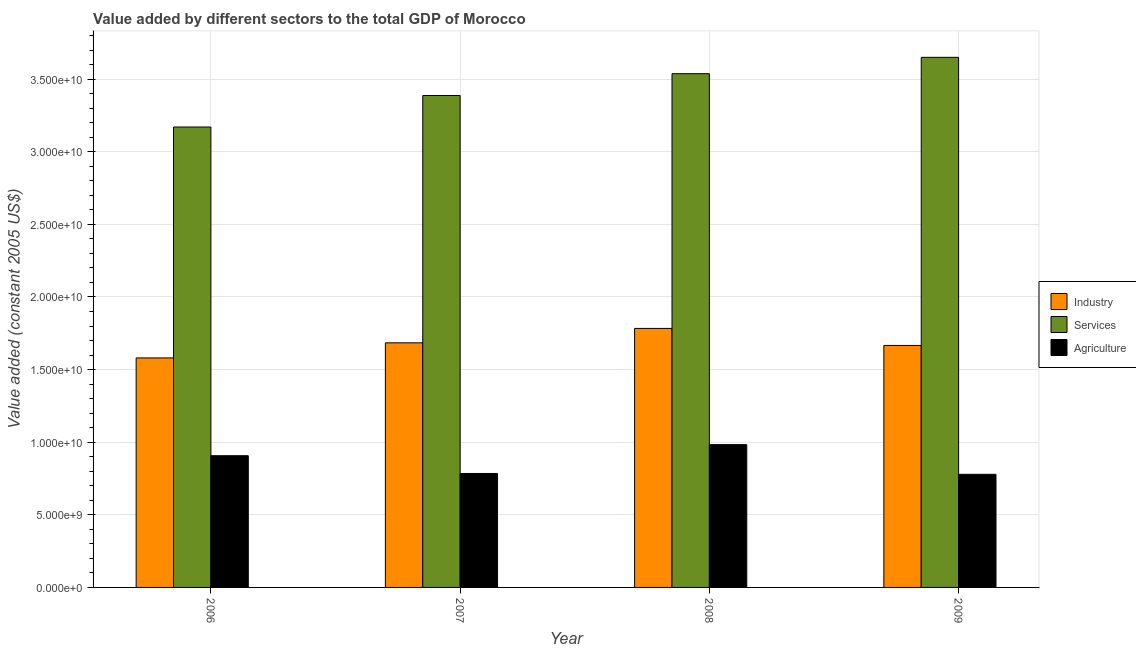How many different coloured bars are there?
Keep it short and to the point. 3. Are the number of bars on each tick of the X-axis equal?
Provide a succinct answer. Yes. How many bars are there on the 3rd tick from the left?
Ensure brevity in your answer.  3. What is the label of the 4th group of bars from the left?
Offer a very short reply. 2009. In how many cases, is the number of bars for a given year not equal to the number of legend labels?
Keep it short and to the point. 0. What is the value added by services in 2008?
Offer a terse response. 3.54e+1. Across all years, what is the maximum value added by services?
Offer a terse response. 3.65e+1. Across all years, what is the minimum value added by industrial sector?
Provide a short and direct response. 1.58e+1. In which year was the value added by services maximum?
Offer a terse response. 2009. In which year was the value added by services minimum?
Provide a short and direct response. 2006. What is the total value added by services in the graph?
Provide a short and direct response. 1.37e+11. What is the difference between the value added by agricultural sector in 2007 and that in 2009?
Provide a short and direct response. 5.80e+07. What is the difference between the value added by agricultural sector in 2007 and the value added by industrial sector in 2006?
Provide a short and direct response. -1.22e+09. What is the average value added by agricultural sector per year?
Give a very brief answer. 8.64e+09. In the year 2008, what is the difference between the value added by services and value added by agricultural sector?
Offer a terse response. 0. What is the ratio of the value added by agricultural sector in 2006 to that in 2008?
Keep it short and to the point. 0.92. Is the value added by services in 2006 less than that in 2008?
Make the answer very short. Yes. What is the difference between the highest and the second highest value added by agricultural sector?
Offer a very short reply. 7.64e+08. What is the difference between the highest and the lowest value added by agricultural sector?
Ensure brevity in your answer.  2.04e+09. In how many years, is the value added by services greater than the average value added by services taken over all years?
Make the answer very short. 2. Is the sum of the value added by industrial sector in 2008 and 2009 greater than the maximum value added by agricultural sector across all years?
Offer a very short reply. Yes. What does the 2nd bar from the left in 2009 represents?
Ensure brevity in your answer.  Services. What does the 1st bar from the right in 2008 represents?
Give a very brief answer. Agriculture. Is it the case that in every year, the sum of the value added by industrial sector and value added by services is greater than the value added by agricultural sector?
Your answer should be very brief. Yes. Are all the bars in the graph horizontal?
Provide a succinct answer. No. How many years are there in the graph?
Ensure brevity in your answer.  4. What is the difference between two consecutive major ticks on the Y-axis?
Make the answer very short. 5.00e+09. Are the values on the major ticks of Y-axis written in scientific E-notation?
Offer a terse response. Yes. Does the graph contain any zero values?
Provide a short and direct response. No. How many legend labels are there?
Give a very brief answer. 3. How are the legend labels stacked?
Provide a short and direct response. Vertical. What is the title of the graph?
Your answer should be very brief. Value added by different sectors to the total GDP of Morocco. Does "Social insurance" appear as one of the legend labels in the graph?
Make the answer very short. No. What is the label or title of the X-axis?
Keep it short and to the point. Year. What is the label or title of the Y-axis?
Provide a short and direct response. Value added (constant 2005 US$). What is the Value added (constant 2005 US$) of Industry in 2006?
Give a very brief answer. 1.58e+1. What is the Value added (constant 2005 US$) in Services in 2006?
Provide a short and direct response. 3.17e+1. What is the Value added (constant 2005 US$) of Agriculture in 2006?
Offer a terse response. 9.07e+09. What is the Value added (constant 2005 US$) of Industry in 2007?
Make the answer very short. 1.68e+1. What is the Value added (constant 2005 US$) in Services in 2007?
Your response must be concise. 3.39e+1. What is the Value added (constant 2005 US$) of Agriculture in 2007?
Your answer should be compact. 7.85e+09. What is the Value added (constant 2005 US$) of Industry in 2008?
Give a very brief answer. 1.78e+1. What is the Value added (constant 2005 US$) of Services in 2008?
Your answer should be very brief. 3.54e+1. What is the Value added (constant 2005 US$) in Agriculture in 2008?
Provide a short and direct response. 9.83e+09. What is the Value added (constant 2005 US$) in Industry in 2009?
Provide a succinct answer. 1.67e+1. What is the Value added (constant 2005 US$) of Services in 2009?
Your response must be concise. 3.65e+1. What is the Value added (constant 2005 US$) of Agriculture in 2009?
Offer a very short reply. 7.79e+09. Across all years, what is the maximum Value added (constant 2005 US$) of Industry?
Make the answer very short. 1.78e+1. Across all years, what is the maximum Value added (constant 2005 US$) of Services?
Make the answer very short. 3.65e+1. Across all years, what is the maximum Value added (constant 2005 US$) of Agriculture?
Offer a terse response. 9.83e+09. Across all years, what is the minimum Value added (constant 2005 US$) of Industry?
Provide a succinct answer. 1.58e+1. Across all years, what is the minimum Value added (constant 2005 US$) in Services?
Give a very brief answer. 3.17e+1. Across all years, what is the minimum Value added (constant 2005 US$) of Agriculture?
Give a very brief answer. 7.79e+09. What is the total Value added (constant 2005 US$) in Industry in the graph?
Provide a short and direct response. 6.71e+1. What is the total Value added (constant 2005 US$) in Services in the graph?
Make the answer very short. 1.37e+11. What is the total Value added (constant 2005 US$) of Agriculture in the graph?
Provide a short and direct response. 3.45e+1. What is the difference between the Value added (constant 2005 US$) of Industry in 2006 and that in 2007?
Your response must be concise. -1.04e+09. What is the difference between the Value added (constant 2005 US$) of Services in 2006 and that in 2007?
Provide a succinct answer. -2.17e+09. What is the difference between the Value added (constant 2005 US$) of Agriculture in 2006 and that in 2007?
Your response must be concise. 1.22e+09. What is the difference between the Value added (constant 2005 US$) of Industry in 2006 and that in 2008?
Provide a short and direct response. -2.03e+09. What is the difference between the Value added (constant 2005 US$) in Services in 2006 and that in 2008?
Your answer should be compact. -3.67e+09. What is the difference between the Value added (constant 2005 US$) in Agriculture in 2006 and that in 2008?
Offer a very short reply. -7.64e+08. What is the difference between the Value added (constant 2005 US$) of Industry in 2006 and that in 2009?
Keep it short and to the point. -8.59e+08. What is the difference between the Value added (constant 2005 US$) of Services in 2006 and that in 2009?
Make the answer very short. -4.80e+09. What is the difference between the Value added (constant 2005 US$) in Agriculture in 2006 and that in 2009?
Provide a succinct answer. 1.28e+09. What is the difference between the Value added (constant 2005 US$) in Industry in 2007 and that in 2008?
Ensure brevity in your answer.  -9.94e+08. What is the difference between the Value added (constant 2005 US$) in Services in 2007 and that in 2008?
Your response must be concise. -1.50e+09. What is the difference between the Value added (constant 2005 US$) of Agriculture in 2007 and that in 2008?
Make the answer very short. -1.99e+09. What is the difference between the Value added (constant 2005 US$) in Industry in 2007 and that in 2009?
Offer a very short reply. 1.79e+08. What is the difference between the Value added (constant 2005 US$) in Services in 2007 and that in 2009?
Keep it short and to the point. -2.63e+09. What is the difference between the Value added (constant 2005 US$) in Agriculture in 2007 and that in 2009?
Provide a succinct answer. 5.80e+07. What is the difference between the Value added (constant 2005 US$) in Industry in 2008 and that in 2009?
Your answer should be compact. 1.17e+09. What is the difference between the Value added (constant 2005 US$) in Services in 2008 and that in 2009?
Your answer should be very brief. -1.13e+09. What is the difference between the Value added (constant 2005 US$) in Agriculture in 2008 and that in 2009?
Keep it short and to the point. 2.04e+09. What is the difference between the Value added (constant 2005 US$) of Industry in 2006 and the Value added (constant 2005 US$) of Services in 2007?
Ensure brevity in your answer.  -1.81e+1. What is the difference between the Value added (constant 2005 US$) of Industry in 2006 and the Value added (constant 2005 US$) of Agriculture in 2007?
Give a very brief answer. 7.96e+09. What is the difference between the Value added (constant 2005 US$) of Services in 2006 and the Value added (constant 2005 US$) of Agriculture in 2007?
Provide a short and direct response. 2.39e+1. What is the difference between the Value added (constant 2005 US$) in Industry in 2006 and the Value added (constant 2005 US$) in Services in 2008?
Offer a very short reply. -1.96e+1. What is the difference between the Value added (constant 2005 US$) of Industry in 2006 and the Value added (constant 2005 US$) of Agriculture in 2008?
Keep it short and to the point. 5.97e+09. What is the difference between the Value added (constant 2005 US$) of Services in 2006 and the Value added (constant 2005 US$) of Agriculture in 2008?
Provide a succinct answer. 2.19e+1. What is the difference between the Value added (constant 2005 US$) in Industry in 2006 and the Value added (constant 2005 US$) in Services in 2009?
Your response must be concise. -2.07e+1. What is the difference between the Value added (constant 2005 US$) in Industry in 2006 and the Value added (constant 2005 US$) in Agriculture in 2009?
Give a very brief answer. 8.02e+09. What is the difference between the Value added (constant 2005 US$) of Services in 2006 and the Value added (constant 2005 US$) of Agriculture in 2009?
Your answer should be very brief. 2.39e+1. What is the difference between the Value added (constant 2005 US$) in Industry in 2007 and the Value added (constant 2005 US$) in Services in 2008?
Your answer should be very brief. -1.85e+1. What is the difference between the Value added (constant 2005 US$) in Industry in 2007 and the Value added (constant 2005 US$) in Agriculture in 2008?
Your answer should be compact. 7.01e+09. What is the difference between the Value added (constant 2005 US$) in Services in 2007 and the Value added (constant 2005 US$) in Agriculture in 2008?
Your answer should be compact. 2.40e+1. What is the difference between the Value added (constant 2005 US$) in Industry in 2007 and the Value added (constant 2005 US$) in Services in 2009?
Provide a succinct answer. -1.97e+1. What is the difference between the Value added (constant 2005 US$) of Industry in 2007 and the Value added (constant 2005 US$) of Agriculture in 2009?
Your answer should be compact. 9.05e+09. What is the difference between the Value added (constant 2005 US$) of Services in 2007 and the Value added (constant 2005 US$) of Agriculture in 2009?
Offer a terse response. 2.61e+1. What is the difference between the Value added (constant 2005 US$) of Industry in 2008 and the Value added (constant 2005 US$) of Services in 2009?
Your answer should be very brief. -1.87e+1. What is the difference between the Value added (constant 2005 US$) in Industry in 2008 and the Value added (constant 2005 US$) in Agriculture in 2009?
Offer a very short reply. 1.00e+1. What is the difference between the Value added (constant 2005 US$) in Services in 2008 and the Value added (constant 2005 US$) in Agriculture in 2009?
Your answer should be very brief. 2.76e+1. What is the average Value added (constant 2005 US$) in Industry per year?
Provide a succinct answer. 1.68e+1. What is the average Value added (constant 2005 US$) in Services per year?
Your response must be concise. 3.44e+1. What is the average Value added (constant 2005 US$) in Agriculture per year?
Keep it short and to the point. 8.64e+09. In the year 2006, what is the difference between the Value added (constant 2005 US$) of Industry and Value added (constant 2005 US$) of Services?
Provide a short and direct response. -1.59e+1. In the year 2006, what is the difference between the Value added (constant 2005 US$) of Industry and Value added (constant 2005 US$) of Agriculture?
Ensure brevity in your answer.  6.73e+09. In the year 2006, what is the difference between the Value added (constant 2005 US$) in Services and Value added (constant 2005 US$) in Agriculture?
Your answer should be very brief. 2.26e+1. In the year 2007, what is the difference between the Value added (constant 2005 US$) in Industry and Value added (constant 2005 US$) in Services?
Make the answer very short. -1.70e+1. In the year 2007, what is the difference between the Value added (constant 2005 US$) in Industry and Value added (constant 2005 US$) in Agriculture?
Make the answer very short. 9.00e+09. In the year 2007, what is the difference between the Value added (constant 2005 US$) of Services and Value added (constant 2005 US$) of Agriculture?
Keep it short and to the point. 2.60e+1. In the year 2008, what is the difference between the Value added (constant 2005 US$) of Industry and Value added (constant 2005 US$) of Services?
Keep it short and to the point. -1.75e+1. In the year 2008, what is the difference between the Value added (constant 2005 US$) in Industry and Value added (constant 2005 US$) in Agriculture?
Your answer should be compact. 8.00e+09. In the year 2008, what is the difference between the Value added (constant 2005 US$) in Services and Value added (constant 2005 US$) in Agriculture?
Keep it short and to the point. 2.55e+1. In the year 2009, what is the difference between the Value added (constant 2005 US$) of Industry and Value added (constant 2005 US$) of Services?
Make the answer very short. -1.98e+1. In the year 2009, what is the difference between the Value added (constant 2005 US$) of Industry and Value added (constant 2005 US$) of Agriculture?
Offer a very short reply. 8.87e+09. In the year 2009, what is the difference between the Value added (constant 2005 US$) of Services and Value added (constant 2005 US$) of Agriculture?
Your answer should be compact. 2.87e+1. What is the ratio of the Value added (constant 2005 US$) of Industry in 2006 to that in 2007?
Your response must be concise. 0.94. What is the ratio of the Value added (constant 2005 US$) in Services in 2006 to that in 2007?
Provide a succinct answer. 0.94. What is the ratio of the Value added (constant 2005 US$) of Agriculture in 2006 to that in 2007?
Offer a terse response. 1.16. What is the ratio of the Value added (constant 2005 US$) of Industry in 2006 to that in 2008?
Your answer should be compact. 0.89. What is the ratio of the Value added (constant 2005 US$) of Services in 2006 to that in 2008?
Offer a very short reply. 0.9. What is the ratio of the Value added (constant 2005 US$) of Agriculture in 2006 to that in 2008?
Make the answer very short. 0.92. What is the ratio of the Value added (constant 2005 US$) of Industry in 2006 to that in 2009?
Keep it short and to the point. 0.95. What is the ratio of the Value added (constant 2005 US$) in Services in 2006 to that in 2009?
Offer a very short reply. 0.87. What is the ratio of the Value added (constant 2005 US$) in Agriculture in 2006 to that in 2009?
Offer a terse response. 1.16. What is the ratio of the Value added (constant 2005 US$) of Industry in 2007 to that in 2008?
Offer a very short reply. 0.94. What is the ratio of the Value added (constant 2005 US$) of Services in 2007 to that in 2008?
Your answer should be very brief. 0.96. What is the ratio of the Value added (constant 2005 US$) in Agriculture in 2007 to that in 2008?
Provide a succinct answer. 0.8. What is the ratio of the Value added (constant 2005 US$) in Industry in 2007 to that in 2009?
Your answer should be compact. 1.01. What is the ratio of the Value added (constant 2005 US$) in Services in 2007 to that in 2009?
Keep it short and to the point. 0.93. What is the ratio of the Value added (constant 2005 US$) in Agriculture in 2007 to that in 2009?
Provide a succinct answer. 1.01. What is the ratio of the Value added (constant 2005 US$) in Industry in 2008 to that in 2009?
Your answer should be very brief. 1.07. What is the ratio of the Value added (constant 2005 US$) in Services in 2008 to that in 2009?
Your answer should be compact. 0.97. What is the ratio of the Value added (constant 2005 US$) of Agriculture in 2008 to that in 2009?
Ensure brevity in your answer.  1.26. What is the difference between the highest and the second highest Value added (constant 2005 US$) in Industry?
Keep it short and to the point. 9.94e+08. What is the difference between the highest and the second highest Value added (constant 2005 US$) in Services?
Your answer should be very brief. 1.13e+09. What is the difference between the highest and the second highest Value added (constant 2005 US$) in Agriculture?
Your answer should be compact. 7.64e+08. What is the difference between the highest and the lowest Value added (constant 2005 US$) of Industry?
Give a very brief answer. 2.03e+09. What is the difference between the highest and the lowest Value added (constant 2005 US$) in Services?
Offer a very short reply. 4.80e+09. What is the difference between the highest and the lowest Value added (constant 2005 US$) of Agriculture?
Your answer should be compact. 2.04e+09. 